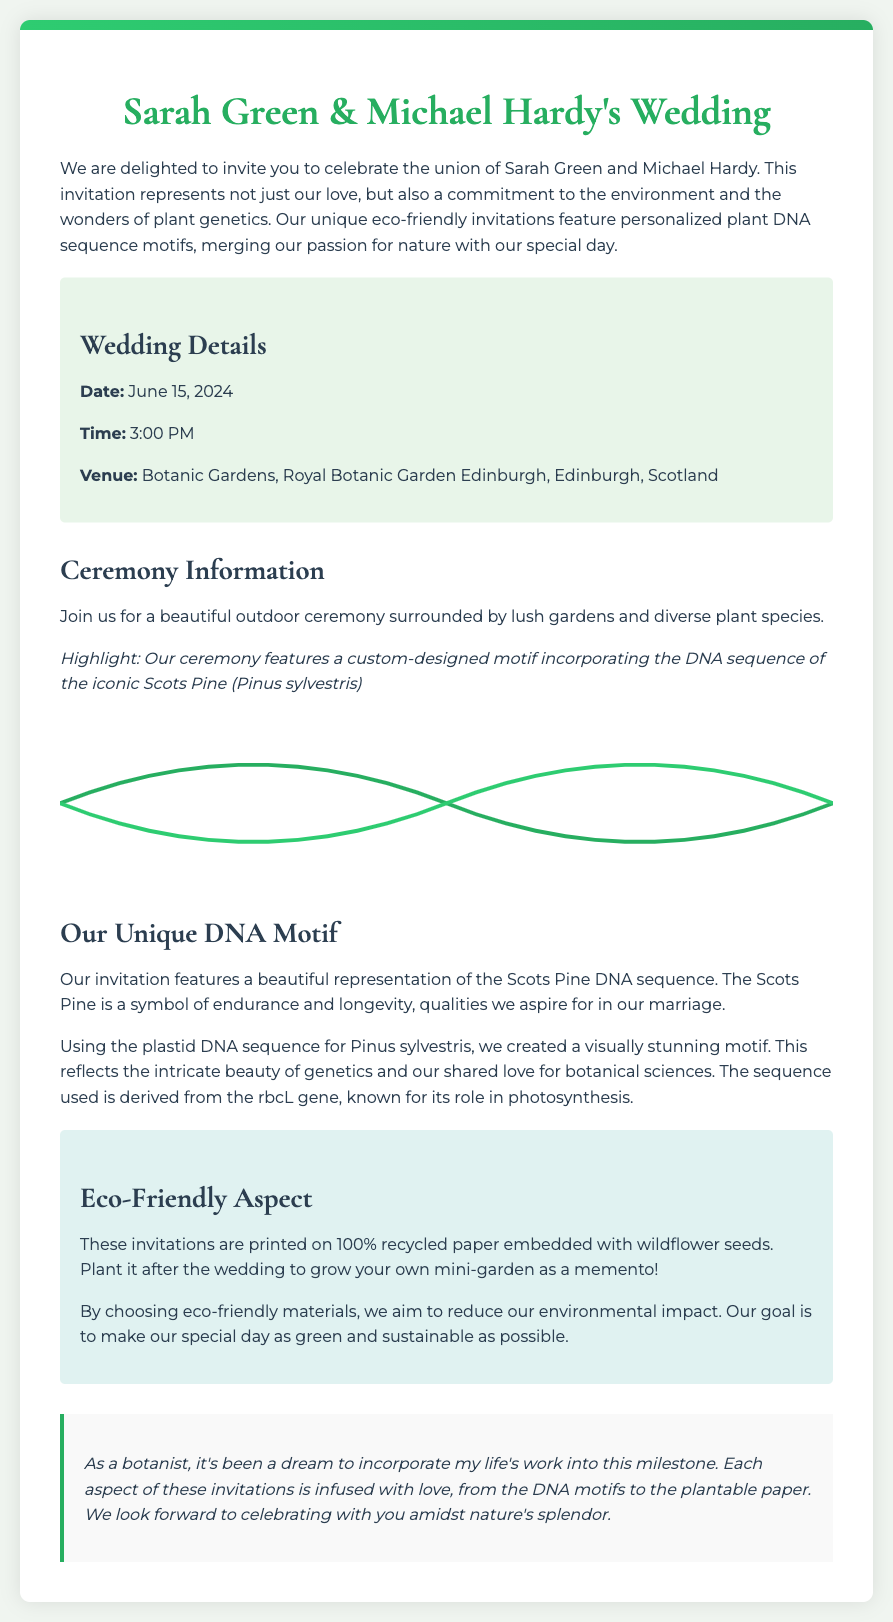What is the wedding date? The date is clearly stated in the wedding details section of the document.
Answer: June 15, 2024 What is the venue for the wedding? The venue is specified in the wedding details section.
Answer: Botanic Gardens, Royal Botanic Garden Edinburgh What is the highlight of the ceremony? The highlight is mentioned in the ceremony information section about the DNA sequence motif.
Answer: Custom-designed motif incorporating the DNA sequence of the iconic Scots Pine Which gene sequence is featured in the DNA motif? The document explicitly identifies the gene used for the Scots Pine motif.
Answer: rbcL gene What type of paper are the invitations printed on? The eco-friendly aspect details the type of paper used for the invitations.
Answer: 100% recycled paper Why did the couple choose eco-friendly materials? The document states their goal in the eco-friendly section.
Answer: To reduce environmental impact What symbol does the Scots Pine represent? The description in the invitation mentions the qualities associated with the Scots Pine.
Answer: Endurance and longevity What is a unique feature of these invitations? The document highlights a specific feature of the invitations that relates to plant science.
Answer: Personalized plant DNA sequence motifs 